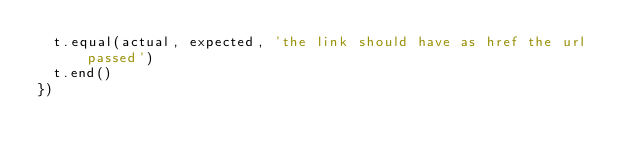Convert code to text. <code><loc_0><loc_0><loc_500><loc_500><_JavaScript_>  t.equal(actual, expected, 'the link should have as href the url passed')
  t.end()
})
</code> 